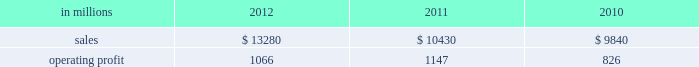( $ 125 million ) and higher maintenance outage costs ( $ 18 million ) .
Additionally , operating profits in 2012 include costs of $ 184 million associated with the acquisition and integration of temple-inland , mill divestiture costs of $ 91 million , costs associated with the restructuring of our european packaging busi- ness of $ 17 million and a $ 3 million gain for other items , while operating costs in 2011 included costs associated with signing an agreement to acquire temple-inland of $ 20 million and a gain of $ 7 million for other items .
Industrial packaging .
North american industr ia l packaging net sales were $ 11.6 billion in 2012 compared with $ 8.6 billion in 2011 and $ 8.4 billion in 2010 .
Operating profits in 2012 were $ 1.0 billion ( $ 1.3 billion exclud- ing costs associated with the acquisition and integration of temple-inland and mill divestiture costs ) compared with $ 1.1 billion ( both including and excluding costs associated with signing an agree- ment to acquire temple-inland ) in 2011 and $ 763 million ( $ 776 million excluding facility closure costs ) in 2010 .
Sales volumes for the legacy business were about flat in 2012 compared with 2011 .
Average sales price was lower mainly due to export containerboard sales prices which bottomed out in the first quarter but climbed steadily the rest of the year .
Input costs were lower for recycled fiber , wood and natural gas , but higher for starch .
Freight costs also increased .
Plan- ned maintenance downtime costs were higher than in 2011 .
Operating costs were higher largely due to routine inventory valuation adjustments operating profits in 2012 benefited from $ 235 million of temple-inland synergies .
Market-related downtime in 2012 was about 570000 tons compared with about 380000 tons in 2011 .
Operating profits in 2012 included $ 184 million of costs associated with the acquisition and integration of temple-inland and $ 91 million of costs associated with the divestiture of three containerboard mills .
Operating profits in 2011 included charges of $ 20 million for costs associated with the signing of the agreement to acquire temple- inland .
Looking ahead to 2013 , sales volumes in the first quarter compared with the fourth quarter of 2012 are expected to increase slightly for boxes due to a higher number of shipping days .
Average sales price realizations are expected to reflect the pass-through to box customers of a containerboard price increase implemented in 2012 .
Input costs are expected to be higher for recycled fiber , wood and starch .
Planned maintenance downtime costs are expected to be about $ 26 million higher with outages scheduled at eight mills compared with six mills in the 2012 fourth quarter .
Manufacturing operating costs are expected to be lower .
European industr ia l packaging net sales were $ 1.0 billion in 2012 compared with $ 1.1 billion in 2011 and $ 990 million in 2010 .
Operating profits in 2012 were $ 53 million ( $ 72 million excluding restructuring costs ) compared with $ 66 million ( $ 61 million excluding a gain for a bargain purchase price adjustment on an acquisition by our joint venture in turkey and costs associated with the closure of our etienne mill in france in 2009 ) in 2011 and $ 70 mil- lion ( $ 73 million before closure costs for our etienne mill ) in 2010 .
Sales volumes in 2012 were lower than in 2011 reflecting decreased demand for packaging in the industrial market due to a weaker overall economic environment in southern europe .
Demand for pack- aging in the agricultural markets was about flat year- over-year .
Average sales margins increased due to sales price increases implemented during 2011 and 2012 and lower board costs .
Other input costs were higher , primarily for energy and distribution .
Operat- ing profits in 2012 included a net gain of $ 10 million for an insurance settlement , partially offset by addi- tional operating costs , related to the earthquakes in northern italy in may which affected our san felice box plant .
Entering the first quarter of 2013 , sales volumes are expected to be stable reflecting a seasonal decrease in market demand in agricultural markets offset by an increase in industrial markets .
Average sales margins are expected to improve due to lower input costs for containerboard .
Other input costs should be about flat .
Operating costs are expected to be higher reflecting the absence of the earthquake insurance settlement that was received in the 2012 fourth quar- asian industr ia l packaging net sales and operating profits include the results of sca pack- aging since the acquisition on june 30 , 2010 , includ- ing the impact of incremental integration costs .
Net sales for the packaging operations were $ 400 million in 2012 compared with $ 410 million in 2011 and $ 255 million in 2010 .
Operating profits for the packaging operations were $ 2 million in 2012 compared with $ 2 million in 2011 and a loss of $ 7 million ( a loss of $ 4 million excluding facility closure costs ) in 2010 .
Operating profits were favorably impacted by higher average sales margins in 2012 compared with 2011 , but this benefit was offset by lower sales volumes and higher raw material costs and operating costs .
Looking ahead to the first quarter of 2013 , sales volumes and average sales margins are expected to decrease due to seasonality .
Net sales for the distribution operations were $ 260 million in 2012 compared with $ 285 million in 2011 and $ 240 million in 2010 .
Operating profits were $ 3 million in 2012 compared with $ 3 million in 2011 and about breakeven in 2010. .
What was the percentage change in the north american industrial packaging net sales in 2012? 
Computations: ((11.6 - 8.6) / 8.6)
Answer: 0.34884. 